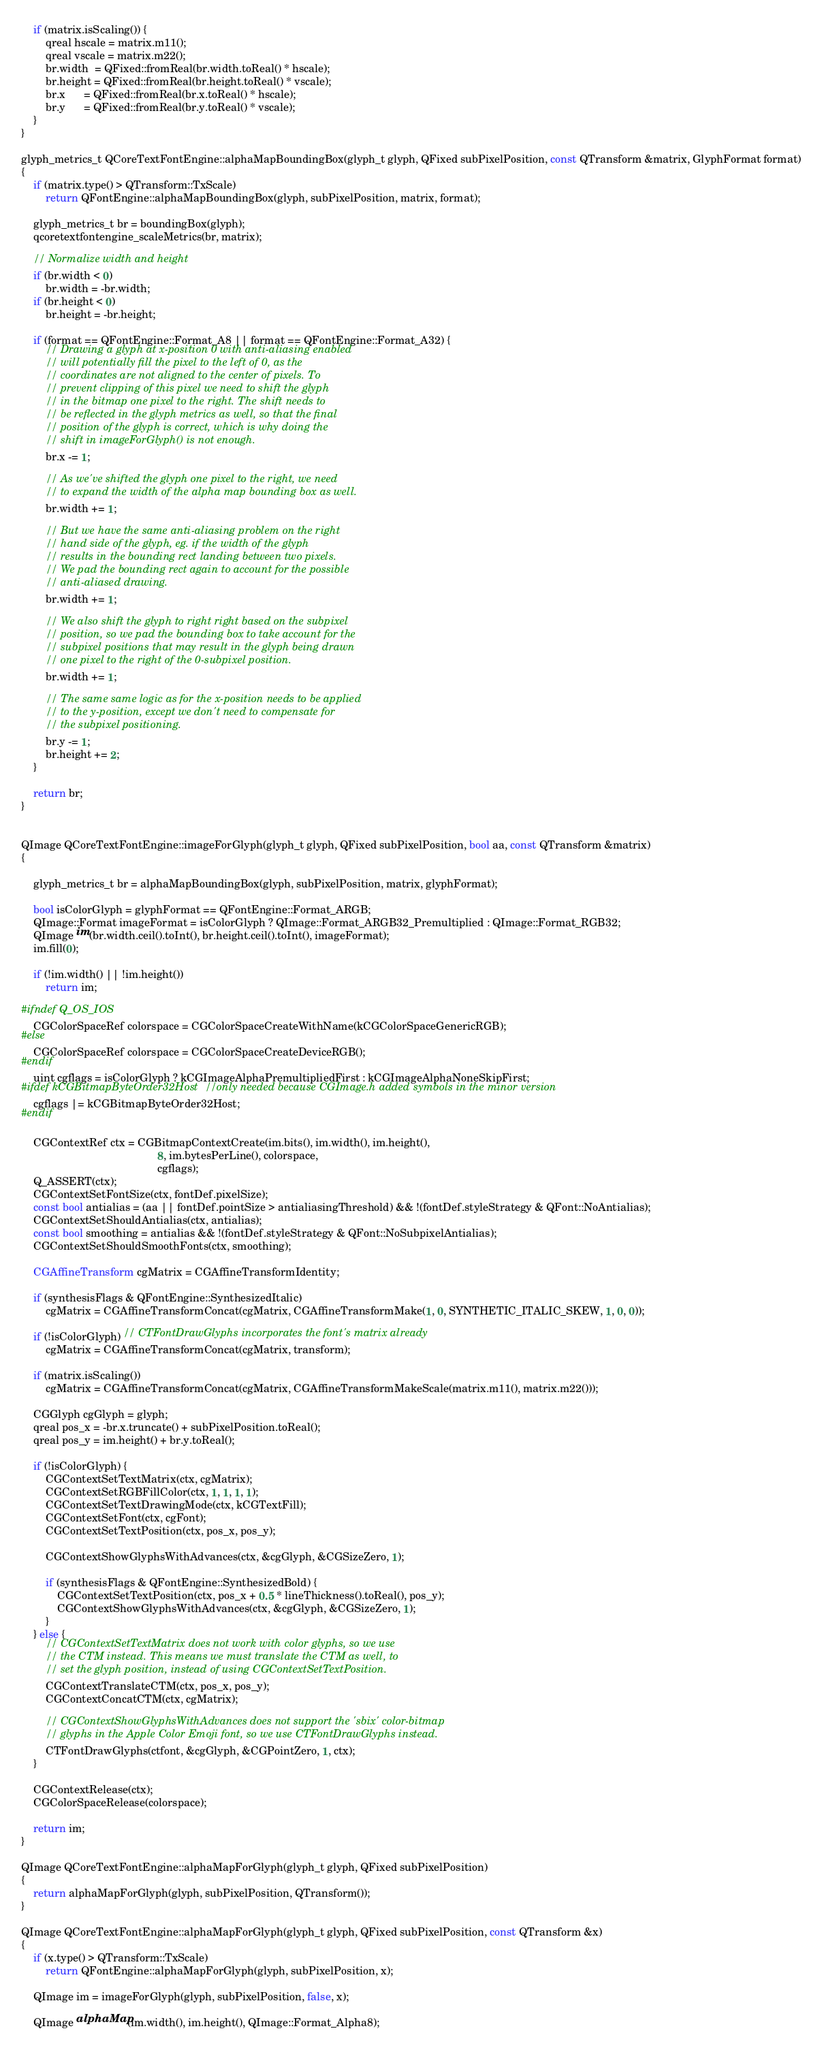<code> <loc_0><loc_0><loc_500><loc_500><_ObjectiveC_>    if (matrix.isScaling()) {
        qreal hscale = matrix.m11();
        qreal vscale = matrix.m22();
        br.width  = QFixed::fromReal(br.width.toReal() * hscale);
        br.height = QFixed::fromReal(br.height.toReal() * vscale);
        br.x      = QFixed::fromReal(br.x.toReal() * hscale);
        br.y      = QFixed::fromReal(br.y.toReal() * vscale);
    }
}

glyph_metrics_t QCoreTextFontEngine::alphaMapBoundingBox(glyph_t glyph, QFixed subPixelPosition, const QTransform &matrix, GlyphFormat format)
{
    if (matrix.type() > QTransform::TxScale)
        return QFontEngine::alphaMapBoundingBox(glyph, subPixelPosition, matrix, format);

    glyph_metrics_t br = boundingBox(glyph);
    qcoretextfontengine_scaleMetrics(br, matrix);

    // Normalize width and height
    if (br.width < 0)
        br.width = -br.width;
    if (br.height < 0)
        br.height = -br.height;

    if (format == QFontEngine::Format_A8 || format == QFontEngine::Format_A32) {
        // Drawing a glyph at x-position 0 with anti-aliasing enabled
        // will potentially fill the pixel to the left of 0, as the
        // coordinates are not aligned to the center of pixels. To
        // prevent clipping of this pixel we need to shift the glyph
        // in the bitmap one pixel to the right. The shift needs to
        // be reflected in the glyph metrics as well, so that the final
        // position of the glyph is correct, which is why doing the
        // shift in imageForGlyph() is not enough.
        br.x -= 1;

        // As we've shifted the glyph one pixel to the right, we need
        // to expand the width of the alpha map bounding box as well.
        br.width += 1;

        // But we have the same anti-aliasing problem on the right
        // hand side of the glyph, eg. if the width of the glyph
        // results in the bounding rect landing between two pixels.
        // We pad the bounding rect again to account for the possible
        // anti-aliased drawing.
        br.width += 1;

        // We also shift the glyph to right right based on the subpixel
        // position, so we pad the bounding box to take account for the
        // subpixel positions that may result in the glyph being drawn
        // one pixel to the right of the 0-subpixel position.
        br.width += 1;

        // The same same logic as for the x-position needs to be applied
        // to the y-position, except we don't need to compensate for
        // the subpixel positioning.
        br.y -= 1;
        br.height += 2;
    }

    return br;
}


QImage QCoreTextFontEngine::imageForGlyph(glyph_t glyph, QFixed subPixelPosition, bool aa, const QTransform &matrix)
{

    glyph_metrics_t br = alphaMapBoundingBox(glyph, subPixelPosition, matrix, glyphFormat);

    bool isColorGlyph = glyphFormat == QFontEngine::Format_ARGB;
    QImage::Format imageFormat = isColorGlyph ? QImage::Format_ARGB32_Premultiplied : QImage::Format_RGB32;
    QImage im(br.width.ceil().toInt(), br.height.ceil().toInt(), imageFormat);
    im.fill(0);

    if (!im.width() || !im.height())
        return im;

#ifndef Q_OS_IOS
    CGColorSpaceRef colorspace = CGColorSpaceCreateWithName(kCGColorSpaceGenericRGB);
#else
    CGColorSpaceRef colorspace = CGColorSpaceCreateDeviceRGB();
#endif
    uint cgflags = isColorGlyph ? kCGImageAlphaPremultipliedFirst : kCGImageAlphaNoneSkipFirst;
#ifdef kCGBitmapByteOrder32Host //only needed because CGImage.h added symbols in the minor version
    cgflags |= kCGBitmapByteOrder32Host;
#endif

    CGContextRef ctx = CGBitmapContextCreate(im.bits(), im.width(), im.height(),
                                             8, im.bytesPerLine(), colorspace,
                                             cgflags);
    Q_ASSERT(ctx);
    CGContextSetFontSize(ctx, fontDef.pixelSize);
    const bool antialias = (aa || fontDef.pointSize > antialiasingThreshold) && !(fontDef.styleStrategy & QFont::NoAntialias);
    CGContextSetShouldAntialias(ctx, antialias);
    const bool smoothing = antialias && !(fontDef.styleStrategy & QFont::NoSubpixelAntialias);
    CGContextSetShouldSmoothFonts(ctx, smoothing);

    CGAffineTransform cgMatrix = CGAffineTransformIdentity;

    if (synthesisFlags & QFontEngine::SynthesizedItalic)
        cgMatrix = CGAffineTransformConcat(cgMatrix, CGAffineTransformMake(1, 0, SYNTHETIC_ITALIC_SKEW, 1, 0, 0));

    if (!isColorGlyph) // CTFontDrawGlyphs incorporates the font's matrix already
        cgMatrix = CGAffineTransformConcat(cgMatrix, transform);

    if (matrix.isScaling())
        cgMatrix = CGAffineTransformConcat(cgMatrix, CGAffineTransformMakeScale(matrix.m11(), matrix.m22()));

    CGGlyph cgGlyph = glyph;
    qreal pos_x = -br.x.truncate() + subPixelPosition.toReal();
    qreal pos_y = im.height() + br.y.toReal();

    if (!isColorGlyph) {
        CGContextSetTextMatrix(ctx, cgMatrix);
        CGContextSetRGBFillColor(ctx, 1, 1, 1, 1);
        CGContextSetTextDrawingMode(ctx, kCGTextFill);
        CGContextSetFont(ctx, cgFont);
        CGContextSetTextPosition(ctx, pos_x, pos_y);

        CGContextShowGlyphsWithAdvances(ctx, &cgGlyph, &CGSizeZero, 1);

        if (synthesisFlags & QFontEngine::SynthesizedBold) {
            CGContextSetTextPosition(ctx, pos_x + 0.5 * lineThickness().toReal(), pos_y);
            CGContextShowGlyphsWithAdvances(ctx, &cgGlyph, &CGSizeZero, 1);
        }
    } else {
        // CGContextSetTextMatrix does not work with color glyphs, so we use
        // the CTM instead. This means we must translate the CTM as well, to
        // set the glyph position, instead of using CGContextSetTextPosition.
        CGContextTranslateCTM(ctx, pos_x, pos_y);
        CGContextConcatCTM(ctx, cgMatrix);

        // CGContextShowGlyphsWithAdvances does not support the 'sbix' color-bitmap
        // glyphs in the Apple Color Emoji font, so we use CTFontDrawGlyphs instead.
        CTFontDrawGlyphs(ctfont, &cgGlyph, &CGPointZero, 1, ctx);
    }

    CGContextRelease(ctx);
    CGColorSpaceRelease(colorspace);

    return im;
}

QImage QCoreTextFontEngine::alphaMapForGlyph(glyph_t glyph, QFixed subPixelPosition)
{
    return alphaMapForGlyph(glyph, subPixelPosition, QTransform());
}

QImage QCoreTextFontEngine::alphaMapForGlyph(glyph_t glyph, QFixed subPixelPosition, const QTransform &x)
{
    if (x.type() > QTransform::TxScale)
        return QFontEngine::alphaMapForGlyph(glyph, subPixelPosition, x);

    QImage im = imageForGlyph(glyph, subPixelPosition, false, x);

    QImage alphaMap(im.width(), im.height(), QImage::Format_Alpha8);
</code> 